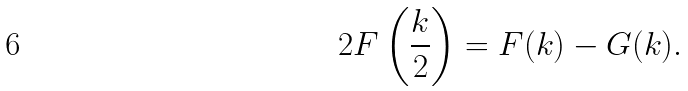<formula> <loc_0><loc_0><loc_500><loc_500>2 F \left ( \frac { k } { 2 } \right ) = F ( k ) - G ( k ) .</formula> 